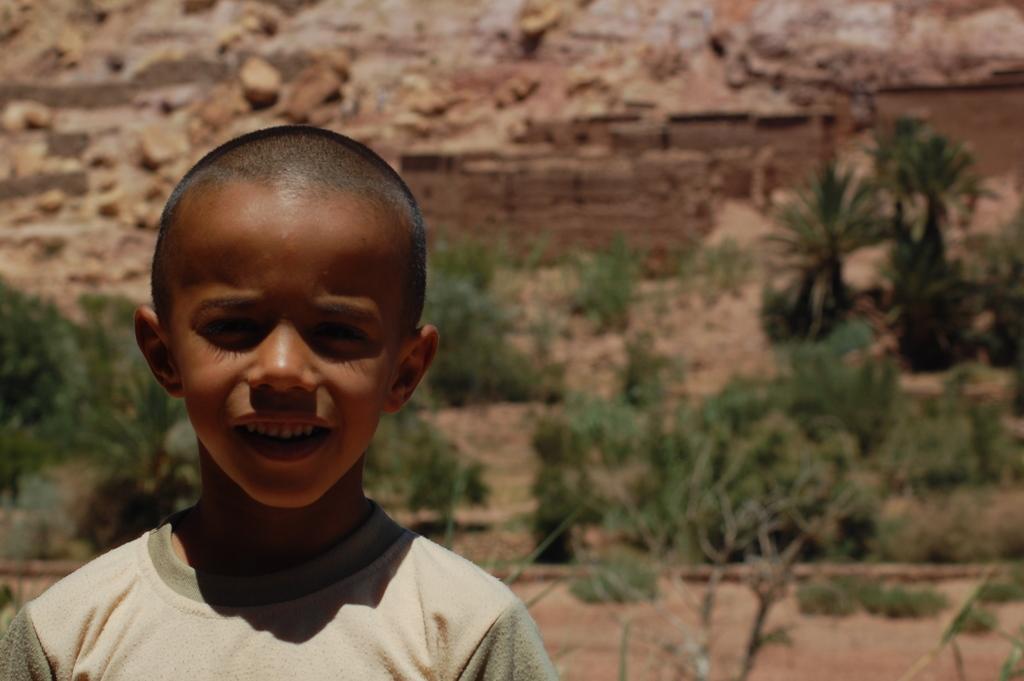Describe this image in one or two sentences. On the left side of the image we can see a kid is smiling. In the background, we can see the grass and soil. 